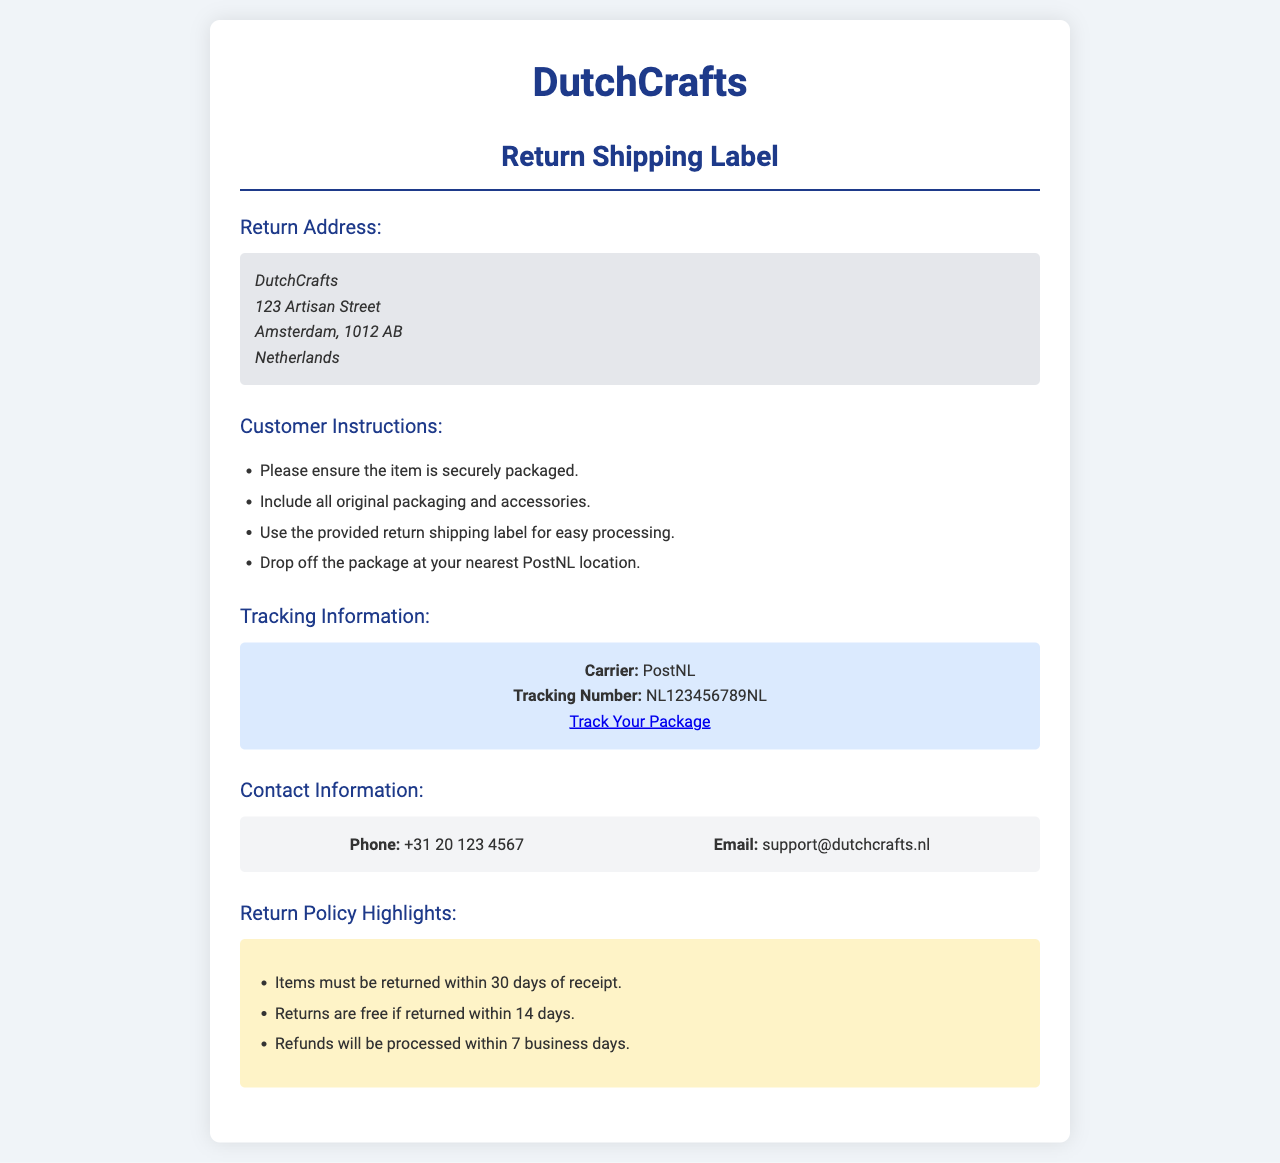what is the return address? The return address is listed in the document under "Return Address", where DutchCrafts is located.
Answer: DutchCrafts, 123 Artisan Street, Amsterdam, 1012 AB, Netherlands what is the tracking number? The tracking number is provided in the "Tracking Information" section, specifically labeled as such.
Answer: NL123456789NL how many days do customers have to return items? The return policy states the time frame for returning items which can be found in the "Return Policy Highlights" section.
Answer: 30 days what action should customers take if they want a refund? To understand the process for a refund, the document indicates the timeframe in the "Return Policy Highlights".
Answer: Processed within 7 business days which carrier is mentioned for tracking? The carrier information is specified in the "Tracking Information" section.
Answer: PostNL are returns free for a specific time frame? The "Return Policy Highlights" outlines conditions under which returns are free.
Answer: 14 days what is the phone number for DutchCrafts support? The contact information provides a phone number for assistance.
Answer: +31 20 123 4567 what should customers include in the return package? Instructions under the "Customer Instructions" section detail what to include in the return package.
Answer: All original packaging and accessories where can customers track their package? The document contains a link to the tracking website in the "Tracking Information" section.
Answer: PostNL website 